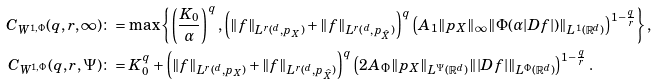Convert formula to latex. <formula><loc_0><loc_0><loc_500><loc_500>C _ { W ^ { 1 , \Phi } } ( q , r , \infty ) & \colon = \max \left \{ \left ( \frac { K _ { 0 } } { \alpha } \right ) ^ { q } , \left ( \| f \| _ { L ^ { r } ( \real ^ { d } , p _ { X } ) } + \| f \| _ { L ^ { r } ( \real ^ { d } , p _ { \widehat { X } } ) } \right ) ^ { q } \left ( A _ { 1 } \| p _ { X } \| _ { \infty } \| \Phi ( \alpha | D f | ) \| _ { L ^ { 1 } ( { \mathbb { R } } ^ { d } ) } \right ) ^ { 1 - \frac { q } { r } } \right \} , \\ C _ { W ^ { 1 , \Phi } } ( q , r , \Psi ) & \colon = K _ { 0 } ^ { q } + \left ( \| f \| _ { L ^ { r } ( \real ^ { d } , p _ { X } ) } + \| f \| _ { L ^ { r } ( \real ^ { d } , p _ { \widehat { X } } ) } \right ) ^ { q } \left ( 2 A _ { \Phi } \| p _ { X } \| _ { L ^ { \Psi } ( { \mathbb { R } } ^ { d } ) } \| | D f | \| _ { L ^ { \Phi } ( { \mathbb { R } } ^ { d } ) } \right ) ^ { 1 - \frac { q } { r } } .</formula> 